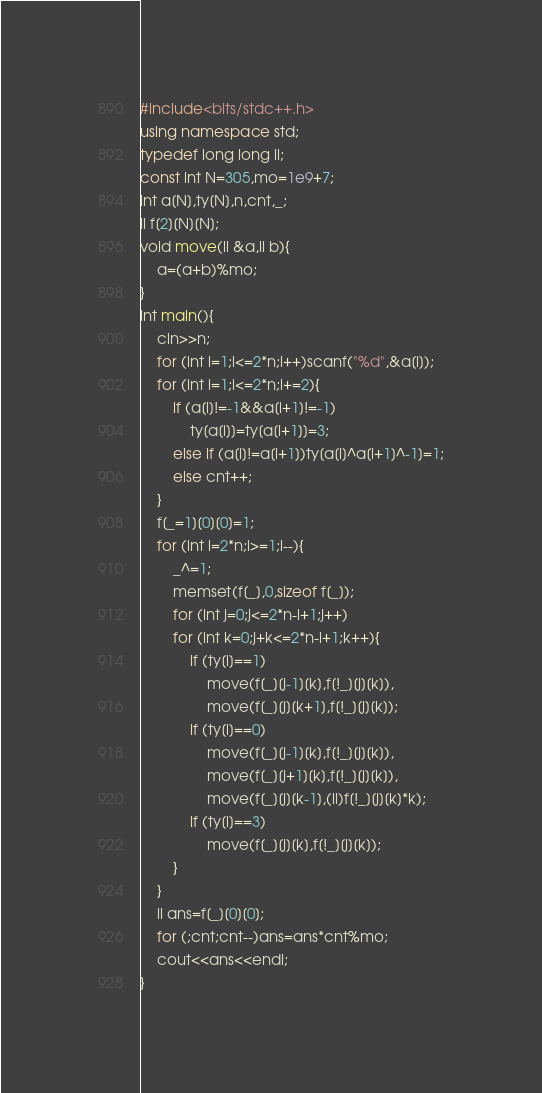<code> <loc_0><loc_0><loc_500><loc_500><_C++_>#include<bits/stdc++.h>
using namespace std;
typedef long long ll;
const int N=305,mo=1e9+7;
int a[N],ty[N],n,cnt,_;
ll f[2][N][N];
void move(ll &a,ll b){
	a=(a+b)%mo;
}
int main(){
	cin>>n;
	for (int i=1;i<=2*n;i++)scanf("%d",&a[i]);
	for (int i=1;i<=2*n;i+=2){
		if (a[i]!=-1&&a[i+1]!=-1)
			ty[a[i]]=ty[a[i+1]]=3;
		else if (a[i]!=a[i+1])ty[a[i]^a[i+1]^-1]=1;
		else cnt++;
	}
	f[_=1][0][0]=1;
	for (int i=2*n;i>=1;i--){
		_^=1;
		memset(f[_],0,sizeof f[_]);
		for (int j=0;j<=2*n-i+1;j++)
		for (int k=0;j+k<=2*n-i+1;k++){
			if (ty[i]==1)
				move(f[_][j-1][k],f[!_][j][k]),
				move(f[_][j][k+1],f[!_][j][k]);
			if (ty[i]==0)
				move(f[_][j-1][k],f[!_][j][k]),
				move(f[_][j+1][k],f[!_][j][k]),
				move(f[_][j][k-1],(ll)f[!_][j][k]*k);
			if (ty[i]==3)
				move(f[_][j][k],f[!_][j][k]);
		}
	}
	ll ans=f[_][0][0];
	for (;cnt;cnt--)ans=ans*cnt%mo;
	cout<<ans<<endl;
}</code> 